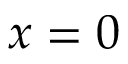<formula> <loc_0><loc_0><loc_500><loc_500>x = 0</formula> 